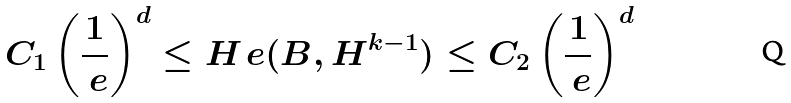Convert formula to latex. <formula><loc_0><loc_0><loc_500><loc_500>C _ { 1 } \left ( \frac { 1 } { \ e } \right ) ^ { d } \leq H _ { \ } e ( B , H ^ { k - 1 } ) \leq C _ { 2 } \left ( \frac { 1 } { \ e } \right ) ^ { d }</formula> 